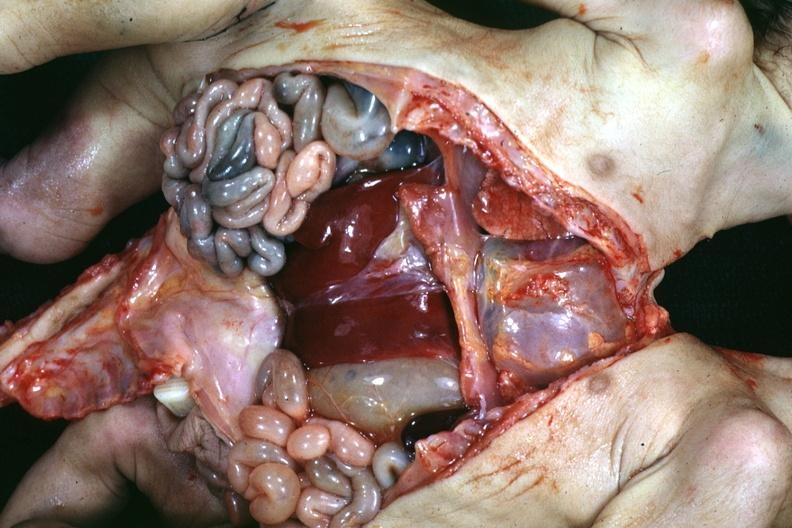how many liver does this image show joined lower chest and abdomen anterior opened lower chest and abdomen showing apparent two sets intestine with?
Answer the question using a single word or phrase. One 